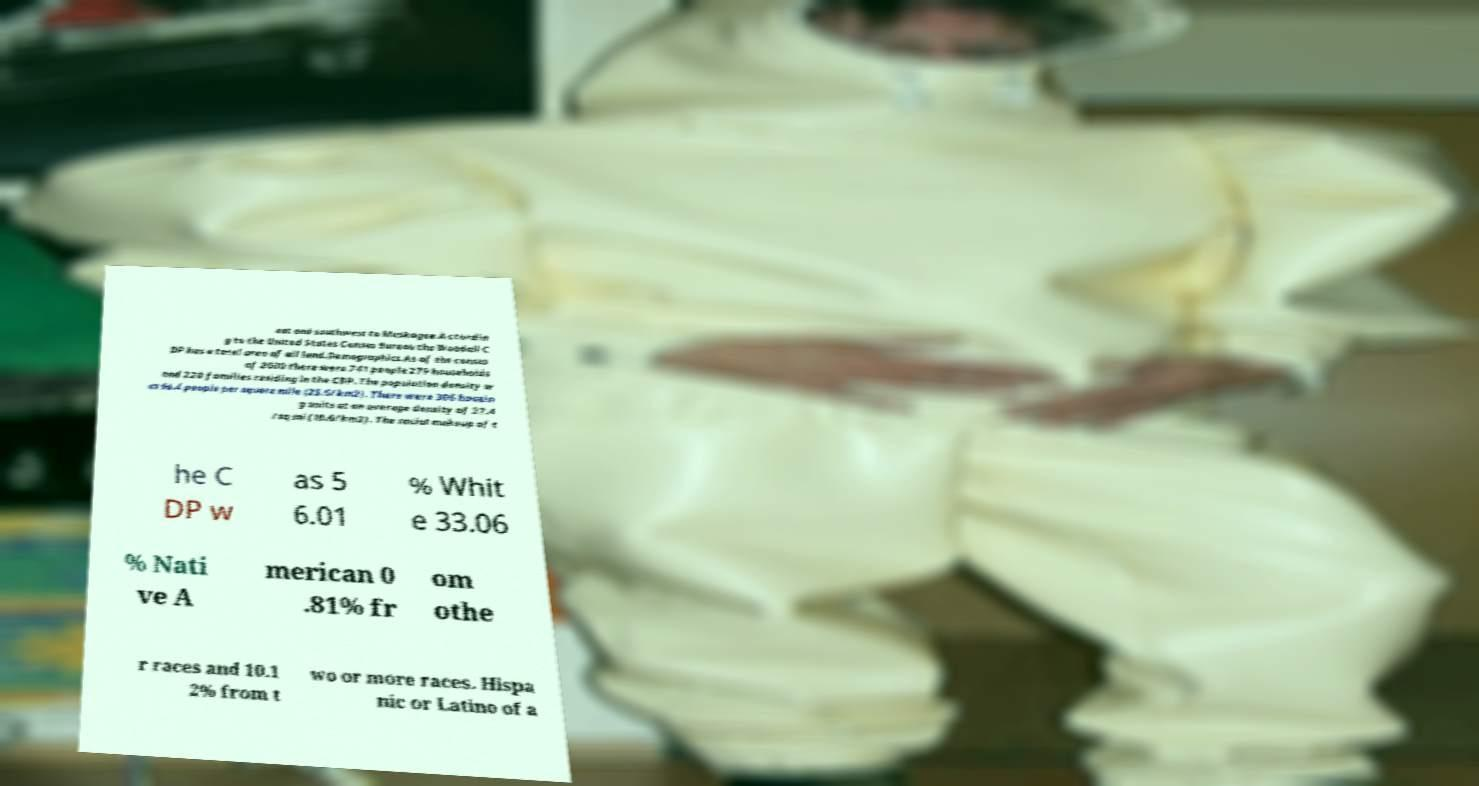Could you assist in decoding the text presented in this image and type it out clearly? eat and southwest to Muskogee.Accordin g to the United States Census Bureau the Woodall C DP has a total area of all land.Demographics.As of the census of 2000 there were 741 people 279 households and 220 families residing in the CDP. The population density w as 66.4 people per square mile (25.6/km2). There were 306 housin g units at an average density of 27.4 /sq mi (10.6/km2). The racial makeup of t he C DP w as 5 6.01 % Whit e 33.06 % Nati ve A merican 0 .81% fr om othe r races and 10.1 2% from t wo or more races. Hispa nic or Latino of a 